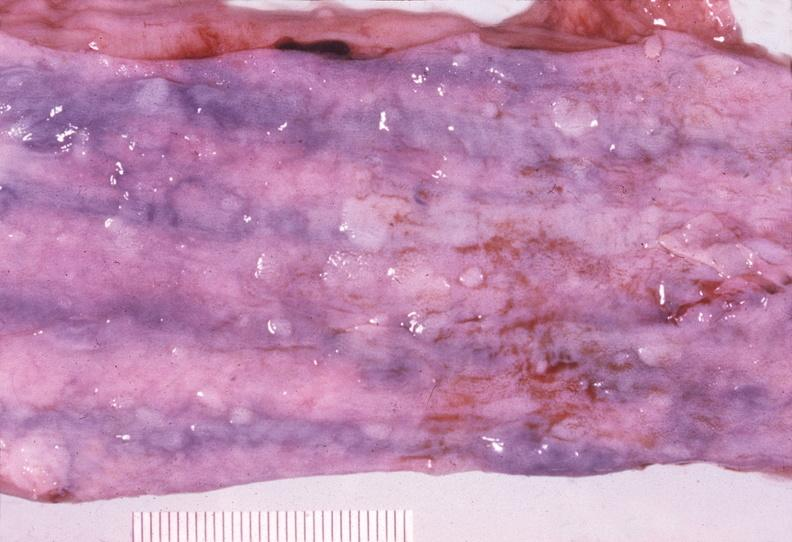s eosinophilic adenoma present?
Answer the question using a single word or phrase. No 